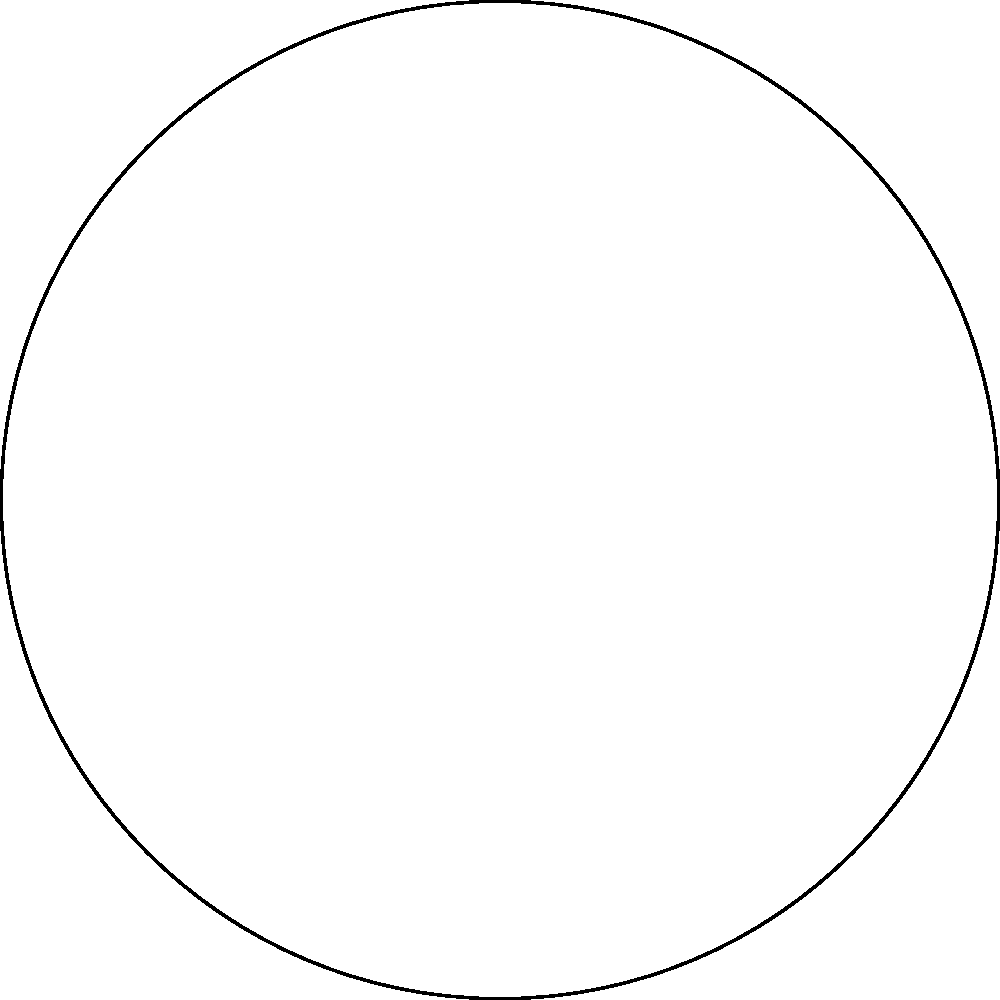In the Poincaré disk model of hyperbolic geometry shown above, which of the following statements is true about the blue and red arcs?

a) They represent parallel lines in hyperbolic geometry
b) They intersect outside the disk
c) They represent perpendicular lines in hyperbolic geometry
d) They represent the same line in hyperbolic geometry To answer this question, let's consider the properties of the Poincaré disk model:

1. The Poincaré disk model represents the entire hyperbolic plane as the interior of a circle.

2. In this model, straight lines in hyperbolic geometry are represented by either:
   a) Diameters of the circle
   b) Circular arcs that intersect the boundary circle at right angles

3. Parallel lines in hyperbolic geometry are represented by circular arcs that do not intersect within the disk but meet at the boundary of the disk.

4. Looking at the given diagram:
   - The blue arc connects points A and B
   - The red arc connects points C and D
   - Both arcs are circular and meet the boundary circle at right angles

5. Importantly, these arcs do not intersect within the disk, but they appear to meet at two points on the boundary of the disk (one on the left and one on the right).

6. This configuration matches the definition of parallel lines in the Poincaré disk model of hyperbolic geometry.

Therefore, the blue and red arcs represent parallel lines in hyperbolic geometry.
Answer: a) They represent parallel lines in hyperbolic geometry 